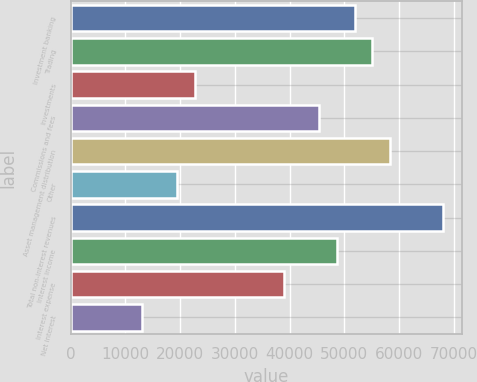Convert chart. <chart><loc_0><loc_0><loc_500><loc_500><bar_chart><fcel>Investment banking<fcel>Trading<fcel>Investments<fcel>Commissions and fees<fcel>Asset management distribution<fcel>Other<fcel>Total non-interest revenues<fcel>Interest income<fcel>Interest expense<fcel>Net interest<nl><fcel>51841.4<fcel>55078.8<fcel>22704.8<fcel>45366.6<fcel>58316.2<fcel>19467.4<fcel>68028.4<fcel>48604<fcel>38891.8<fcel>12992.6<nl></chart> 